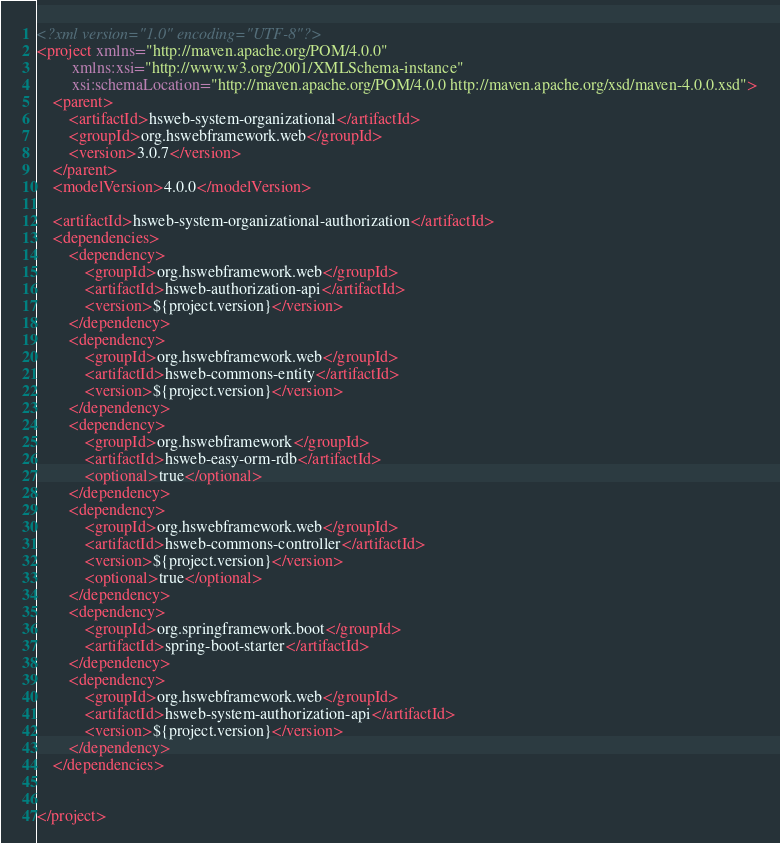<code> <loc_0><loc_0><loc_500><loc_500><_XML_><?xml version="1.0" encoding="UTF-8"?>
<project xmlns="http://maven.apache.org/POM/4.0.0"
         xmlns:xsi="http://www.w3.org/2001/XMLSchema-instance"
         xsi:schemaLocation="http://maven.apache.org/POM/4.0.0 http://maven.apache.org/xsd/maven-4.0.0.xsd">
    <parent>
        <artifactId>hsweb-system-organizational</artifactId>
        <groupId>org.hswebframework.web</groupId>
        <version>3.0.7</version>
    </parent>
    <modelVersion>4.0.0</modelVersion>

    <artifactId>hsweb-system-organizational-authorization</artifactId>
    <dependencies>
        <dependency>
            <groupId>org.hswebframework.web</groupId>
            <artifactId>hsweb-authorization-api</artifactId>
            <version>${project.version}</version>
        </dependency>
        <dependency>
            <groupId>org.hswebframework.web</groupId>
            <artifactId>hsweb-commons-entity</artifactId>
            <version>${project.version}</version>
        </dependency>
        <dependency>
            <groupId>org.hswebframework</groupId>
            <artifactId>hsweb-easy-orm-rdb</artifactId>
            <optional>true</optional>
        </dependency>
        <dependency>
            <groupId>org.hswebframework.web</groupId>
            <artifactId>hsweb-commons-controller</artifactId>
            <version>${project.version}</version>
            <optional>true</optional>
        </dependency>
        <dependency>
            <groupId>org.springframework.boot</groupId>
            <artifactId>spring-boot-starter</artifactId>
        </dependency>
        <dependency>
            <groupId>org.hswebframework.web</groupId>
            <artifactId>hsweb-system-authorization-api</artifactId>
            <version>${project.version}</version>
        </dependency>
    </dependencies>


</project></code> 